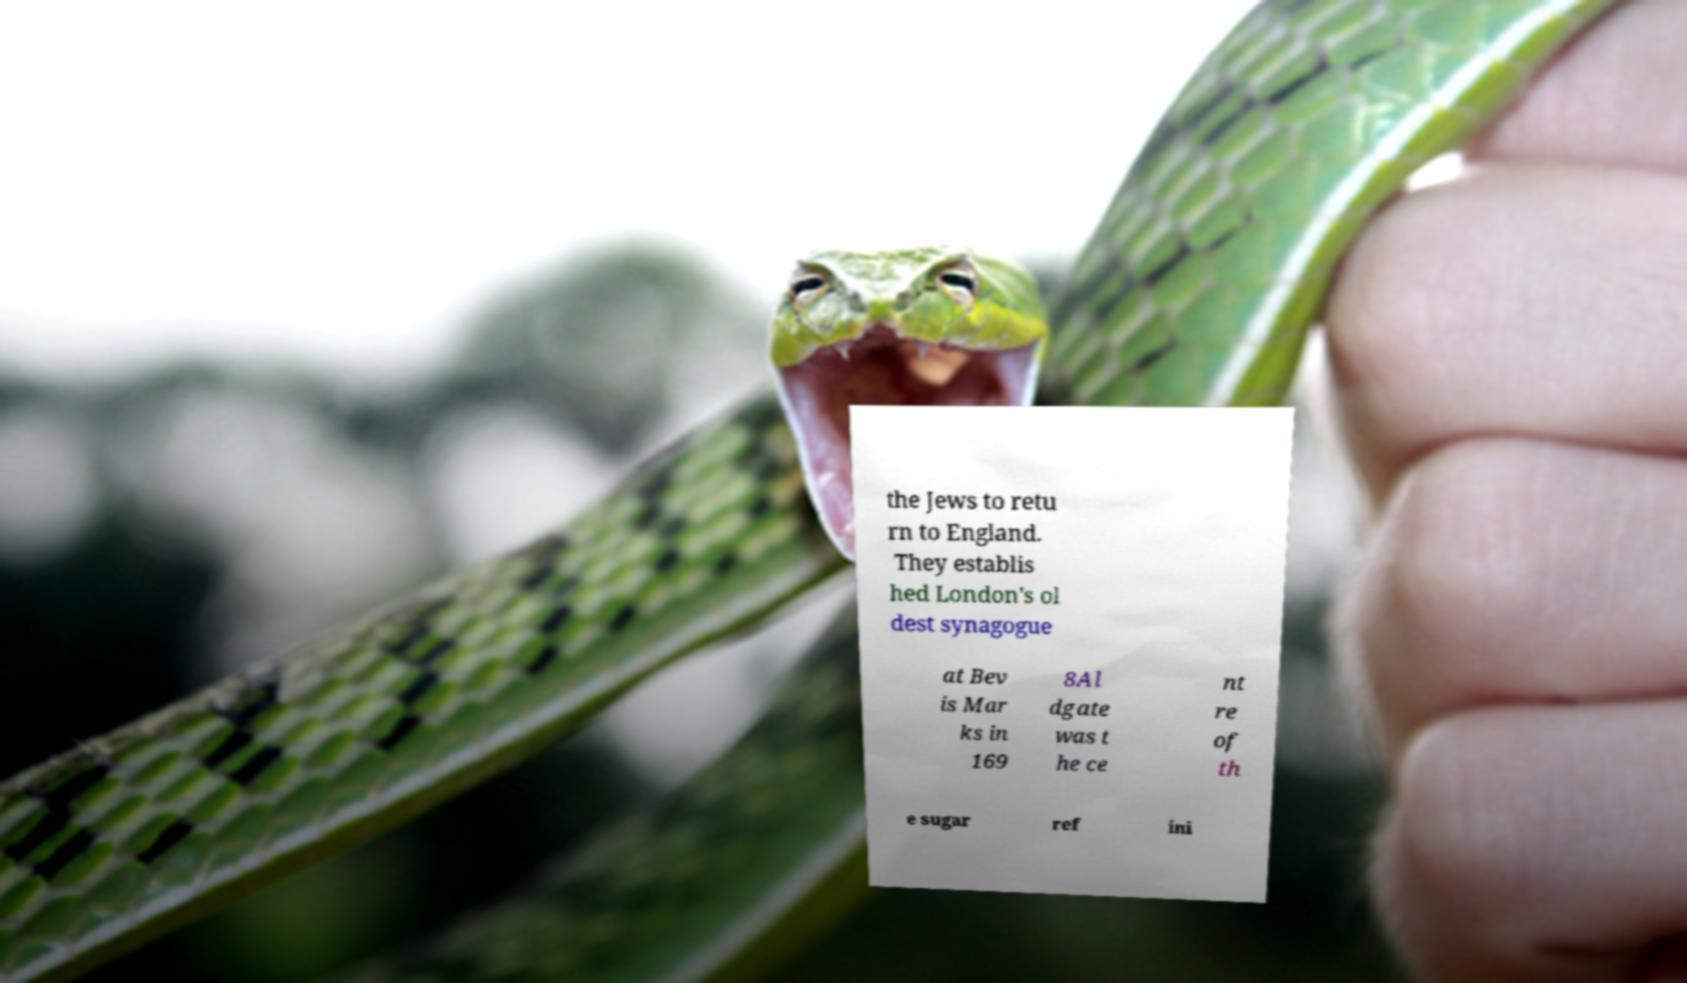Can you accurately transcribe the text from the provided image for me? the Jews to retu rn to England. They establis hed London's ol dest synagogue at Bev is Mar ks in 169 8Al dgate was t he ce nt re of th e sugar ref ini 